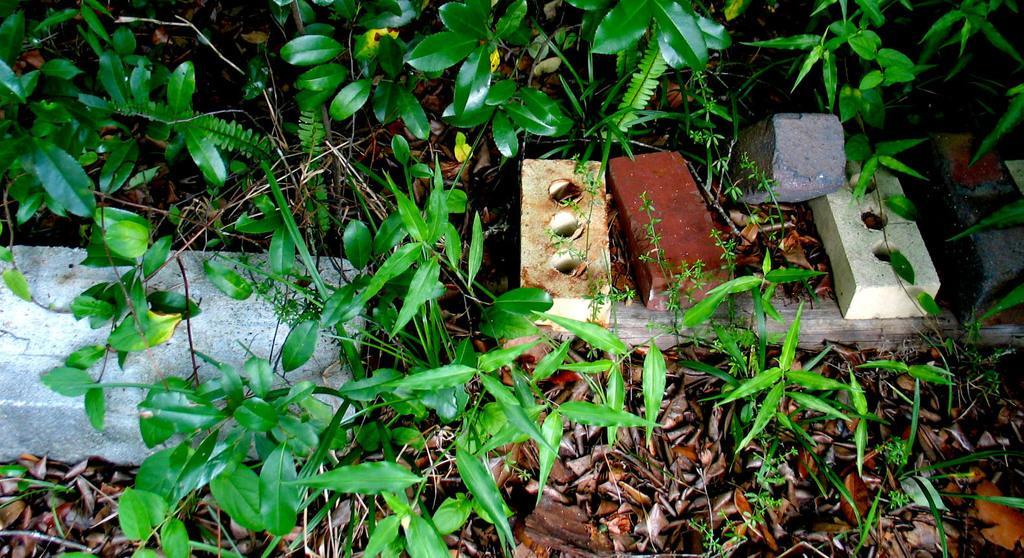Can you describe this image briefly? In this picture I can observe bricks on the land. I can observe some dried leaves on the ground. I can observe some plants which are in green color. 